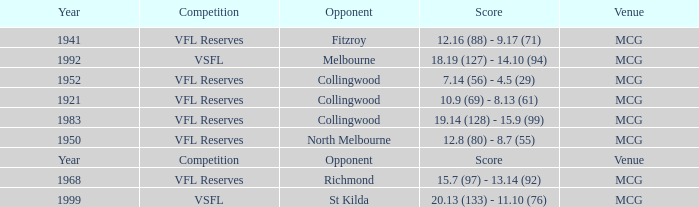In what competition was the score reported as 12.8 (80) - 8.7 (55)? VFL Reserves. 